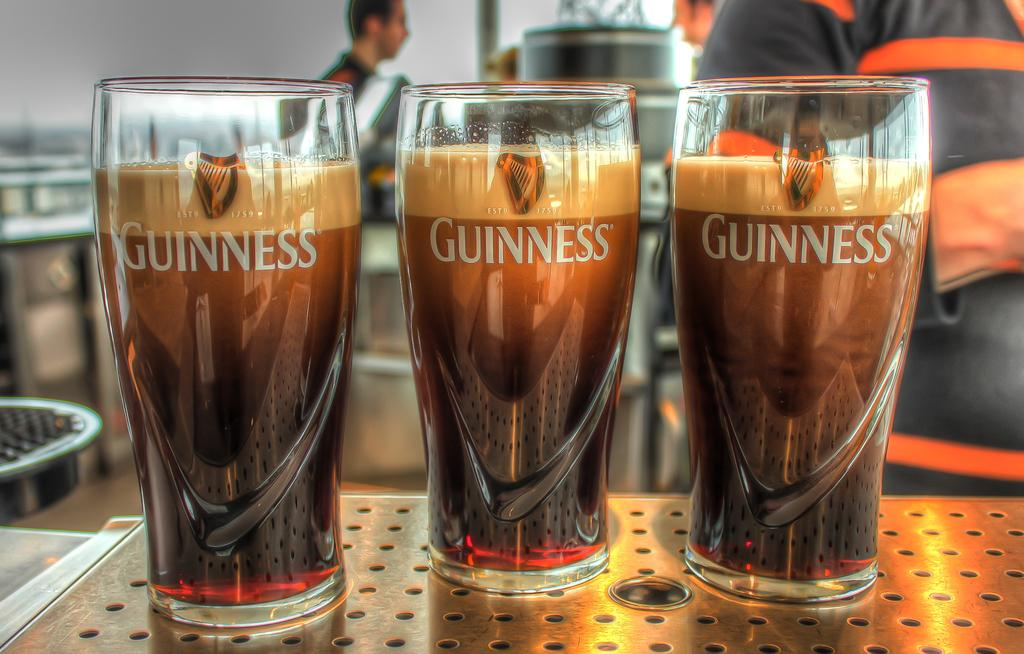<image>
Offer a succinct explanation of the picture presented. 3 Guinness Beer Glasses poured to the top. 